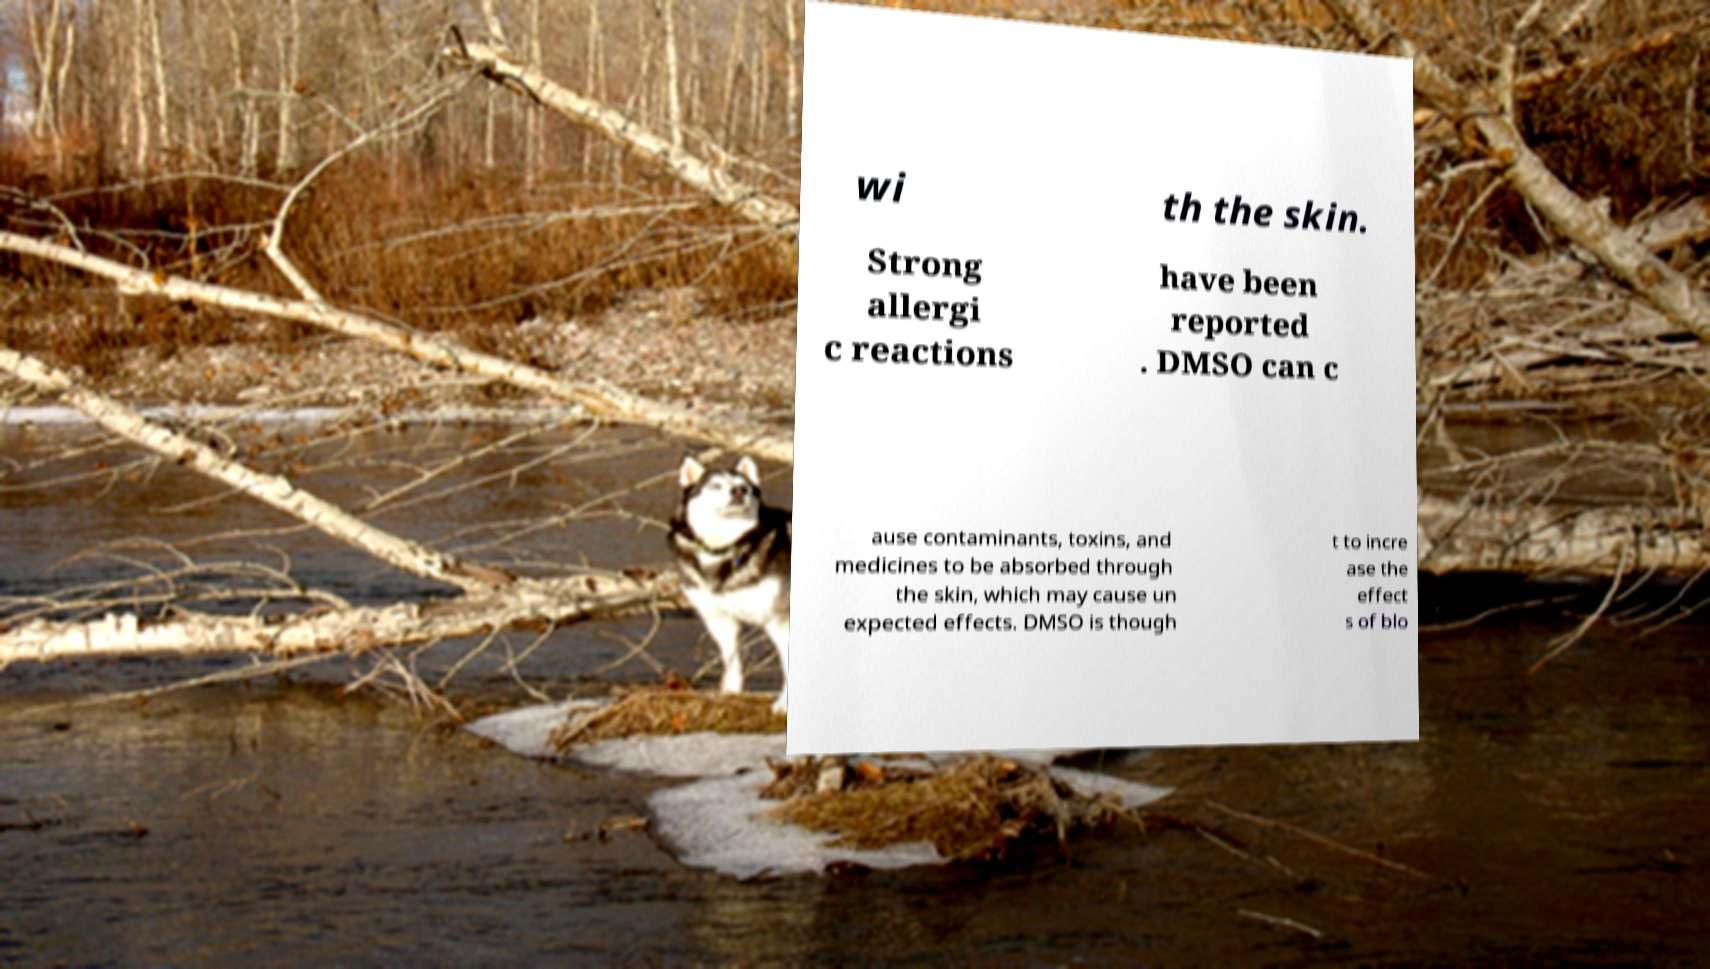Can you accurately transcribe the text from the provided image for me? wi th the skin. Strong allergi c reactions have been reported . DMSO can c ause contaminants, toxins, and medicines to be absorbed through the skin, which may cause un expected effects. DMSO is though t to incre ase the effect s of blo 